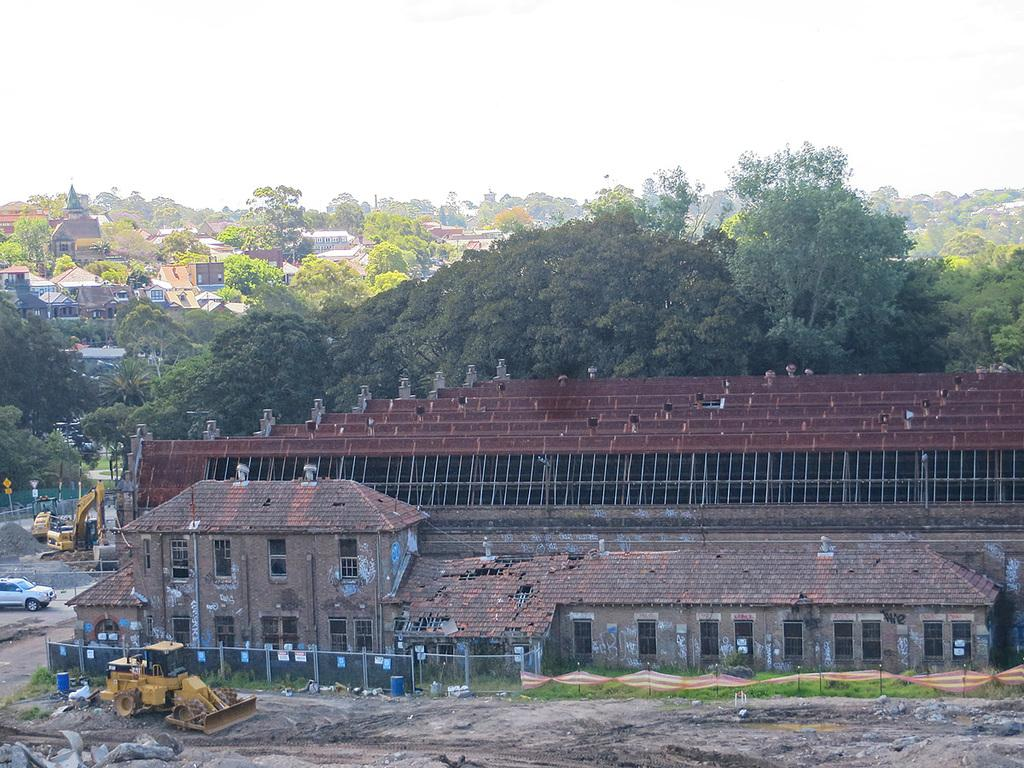What is present in the foreground of the image? There is mud, houses, and a vehicle in the foreground of the image. What can be seen in the middle of the image? There are houses and trees in the middle of the image. What is visible at the top of the image? The sky is visible at the top of the image. Can you tell me how many geese are depicted in the image? There are no geese present in the image. What type of coat is the person wearing in the image? There are no people or coats visible in the image. 